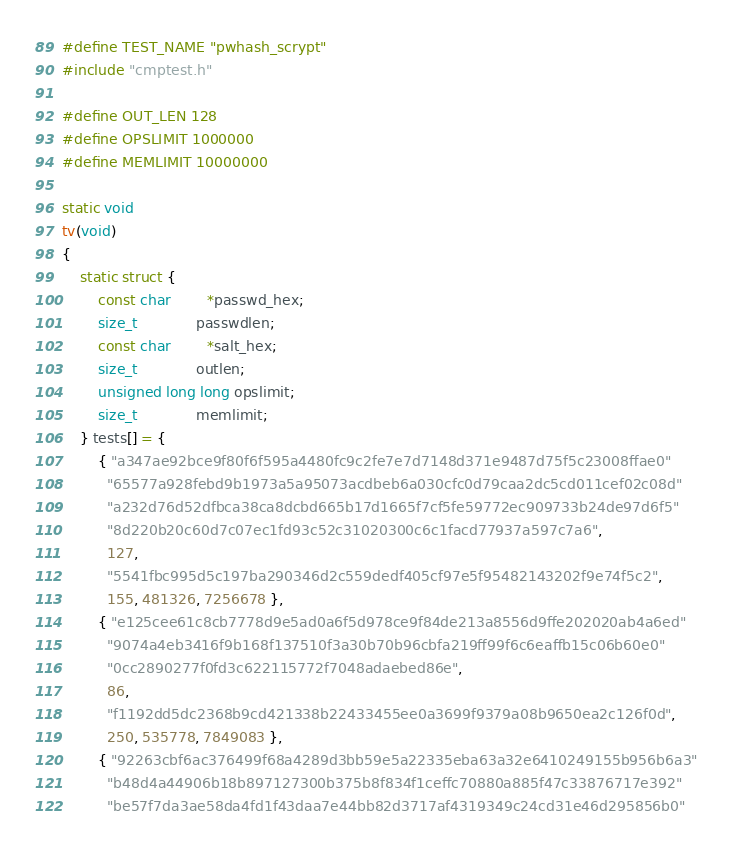<code> <loc_0><loc_0><loc_500><loc_500><_C_>
#define TEST_NAME "pwhash_scrypt"
#include "cmptest.h"

#define OUT_LEN 128
#define OPSLIMIT 1000000
#define MEMLIMIT 10000000

static void
tv(void)
{
    static struct {
        const char        *passwd_hex;
        size_t             passwdlen;
        const char        *salt_hex;
        size_t             outlen;
        unsigned long long opslimit;
        size_t             memlimit;
    } tests[] = {
        { "a347ae92bce9f80f6f595a4480fc9c2fe7e7d7148d371e9487d75f5c23008ffae0"
          "65577a928febd9b1973a5a95073acdbeb6a030cfc0d79caa2dc5cd011cef02c08d"
          "a232d76d52dfbca38ca8dcbd665b17d1665f7cf5fe59772ec909733b24de97d6f5"
          "8d220b20c60d7c07ec1fd93c52c31020300c6c1facd77937a597c7a6",
          127,
          "5541fbc995d5c197ba290346d2c559dedf405cf97e5f95482143202f9e74f5c2",
          155, 481326, 7256678 },
        { "e125cee61c8cb7778d9e5ad0a6f5d978ce9f84de213a8556d9ffe202020ab4a6ed"
          "9074a4eb3416f9b168f137510f3a30b70b96cbfa219ff99f6c6eaffb15c06b60e0"
          "0cc2890277f0fd3c622115772f7048adaebed86e",
          86,
          "f1192dd5dc2368b9cd421338b22433455ee0a3699f9379a08b9650ea2c126f0d",
          250, 535778, 7849083 },
        { "92263cbf6ac376499f68a4289d3bb59e5a22335eba63a32e6410249155b956b6a3"
          "b48d4a44906b18b897127300b375b8f834f1ceffc70880a885f47c33876717e392"
          "be57f7da3ae58da4fd1f43daa7e44bb82d3717af4319349c24cd31e46d295856b0"</code> 